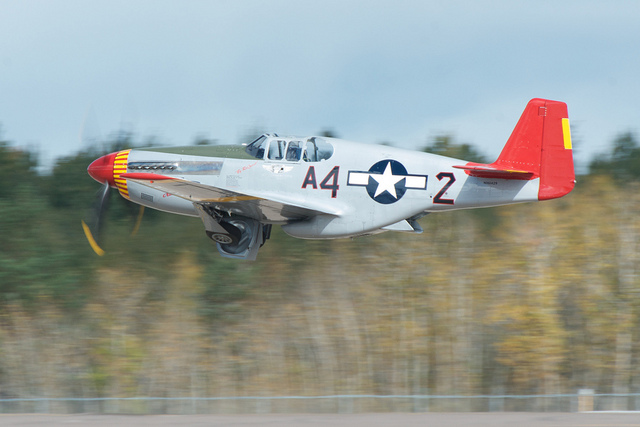How is such an aircraft typically maintained to keep it airworthy? Maintaining vintage aircraft like this requires meticulous work, including regular mechanical inspections, preserving the integrity of historical components, and sometimes using modern parts and technologies to ensure safety while respecting the aircraft's original design and heritage. 